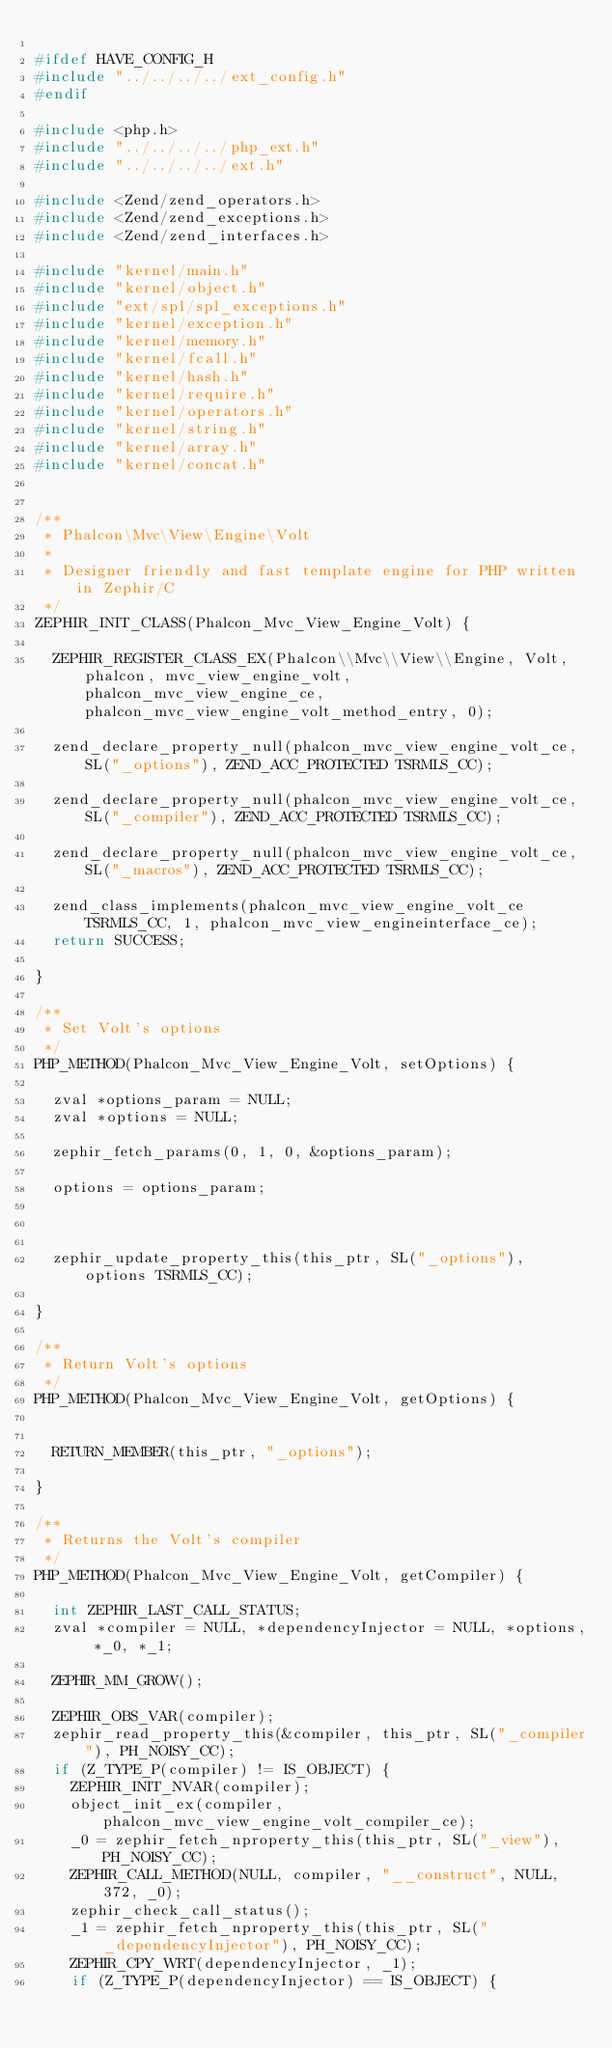Convert code to text. <code><loc_0><loc_0><loc_500><loc_500><_C_>
#ifdef HAVE_CONFIG_H
#include "../../../../ext_config.h"
#endif

#include <php.h>
#include "../../../../php_ext.h"
#include "../../../../ext.h"

#include <Zend/zend_operators.h>
#include <Zend/zend_exceptions.h>
#include <Zend/zend_interfaces.h>

#include "kernel/main.h"
#include "kernel/object.h"
#include "ext/spl/spl_exceptions.h"
#include "kernel/exception.h"
#include "kernel/memory.h"
#include "kernel/fcall.h"
#include "kernel/hash.h"
#include "kernel/require.h"
#include "kernel/operators.h"
#include "kernel/string.h"
#include "kernel/array.h"
#include "kernel/concat.h"


/**
 * Phalcon\Mvc\View\Engine\Volt
 *
 * Designer friendly and fast template engine for PHP written in Zephir/C
 */
ZEPHIR_INIT_CLASS(Phalcon_Mvc_View_Engine_Volt) {

	ZEPHIR_REGISTER_CLASS_EX(Phalcon\\Mvc\\View\\Engine, Volt, phalcon, mvc_view_engine_volt, phalcon_mvc_view_engine_ce, phalcon_mvc_view_engine_volt_method_entry, 0);

	zend_declare_property_null(phalcon_mvc_view_engine_volt_ce, SL("_options"), ZEND_ACC_PROTECTED TSRMLS_CC);

	zend_declare_property_null(phalcon_mvc_view_engine_volt_ce, SL("_compiler"), ZEND_ACC_PROTECTED TSRMLS_CC);

	zend_declare_property_null(phalcon_mvc_view_engine_volt_ce, SL("_macros"), ZEND_ACC_PROTECTED TSRMLS_CC);

	zend_class_implements(phalcon_mvc_view_engine_volt_ce TSRMLS_CC, 1, phalcon_mvc_view_engineinterface_ce);
	return SUCCESS;

}

/**
 * Set Volt's options
 */
PHP_METHOD(Phalcon_Mvc_View_Engine_Volt, setOptions) {

	zval *options_param = NULL;
	zval *options = NULL;

	zephir_fetch_params(0, 1, 0, &options_param);

	options = options_param;



	zephir_update_property_this(this_ptr, SL("_options"), options TSRMLS_CC);

}

/**
 * Return Volt's options
 */
PHP_METHOD(Phalcon_Mvc_View_Engine_Volt, getOptions) {


	RETURN_MEMBER(this_ptr, "_options");

}

/**
 * Returns the Volt's compiler
 */
PHP_METHOD(Phalcon_Mvc_View_Engine_Volt, getCompiler) {

	int ZEPHIR_LAST_CALL_STATUS;
	zval *compiler = NULL, *dependencyInjector = NULL, *options, *_0, *_1;

	ZEPHIR_MM_GROW();

	ZEPHIR_OBS_VAR(compiler);
	zephir_read_property_this(&compiler, this_ptr, SL("_compiler"), PH_NOISY_CC);
	if (Z_TYPE_P(compiler) != IS_OBJECT) {
		ZEPHIR_INIT_NVAR(compiler);
		object_init_ex(compiler, phalcon_mvc_view_engine_volt_compiler_ce);
		_0 = zephir_fetch_nproperty_this(this_ptr, SL("_view"), PH_NOISY_CC);
		ZEPHIR_CALL_METHOD(NULL, compiler, "__construct", NULL, 372, _0);
		zephir_check_call_status();
		_1 = zephir_fetch_nproperty_this(this_ptr, SL("_dependencyInjector"), PH_NOISY_CC);
		ZEPHIR_CPY_WRT(dependencyInjector, _1);
		if (Z_TYPE_P(dependencyInjector) == IS_OBJECT) {</code> 